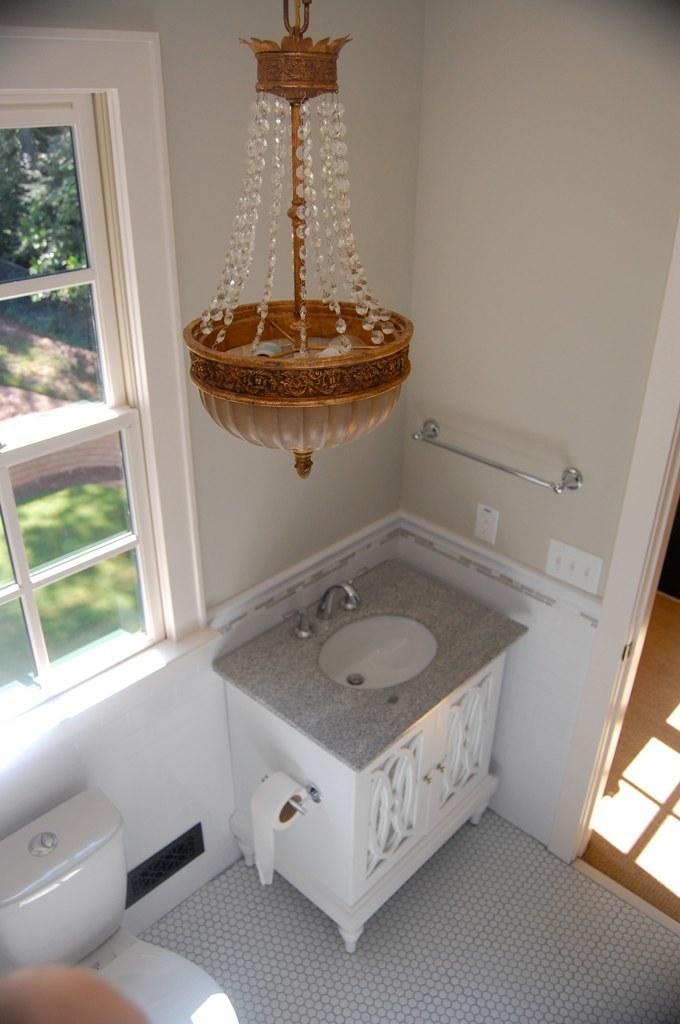Please provide a concise description of this image. This image is a top view picture of a room. In the center of the image there is a sink. In the background of the image there is a wall. There is a window through which we can see trees. At the bottom of the image there is a toilet seat. There is floor. To the right side of the image there is a door. 